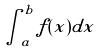<formula> <loc_0><loc_0><loc_500><loc_500>\int _ { a } ^ { b } f ( x ) d x</formula> 